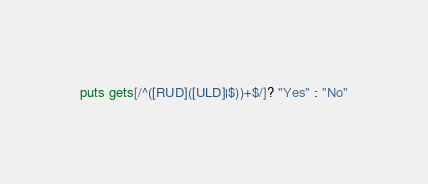Convert code to text. <code><loc_0><loc_0><loc_500><loc_500><_Ruby_>puts gets[/^([RUD]([ULD]|$))+$/]? "Yes" : "No"</code> 